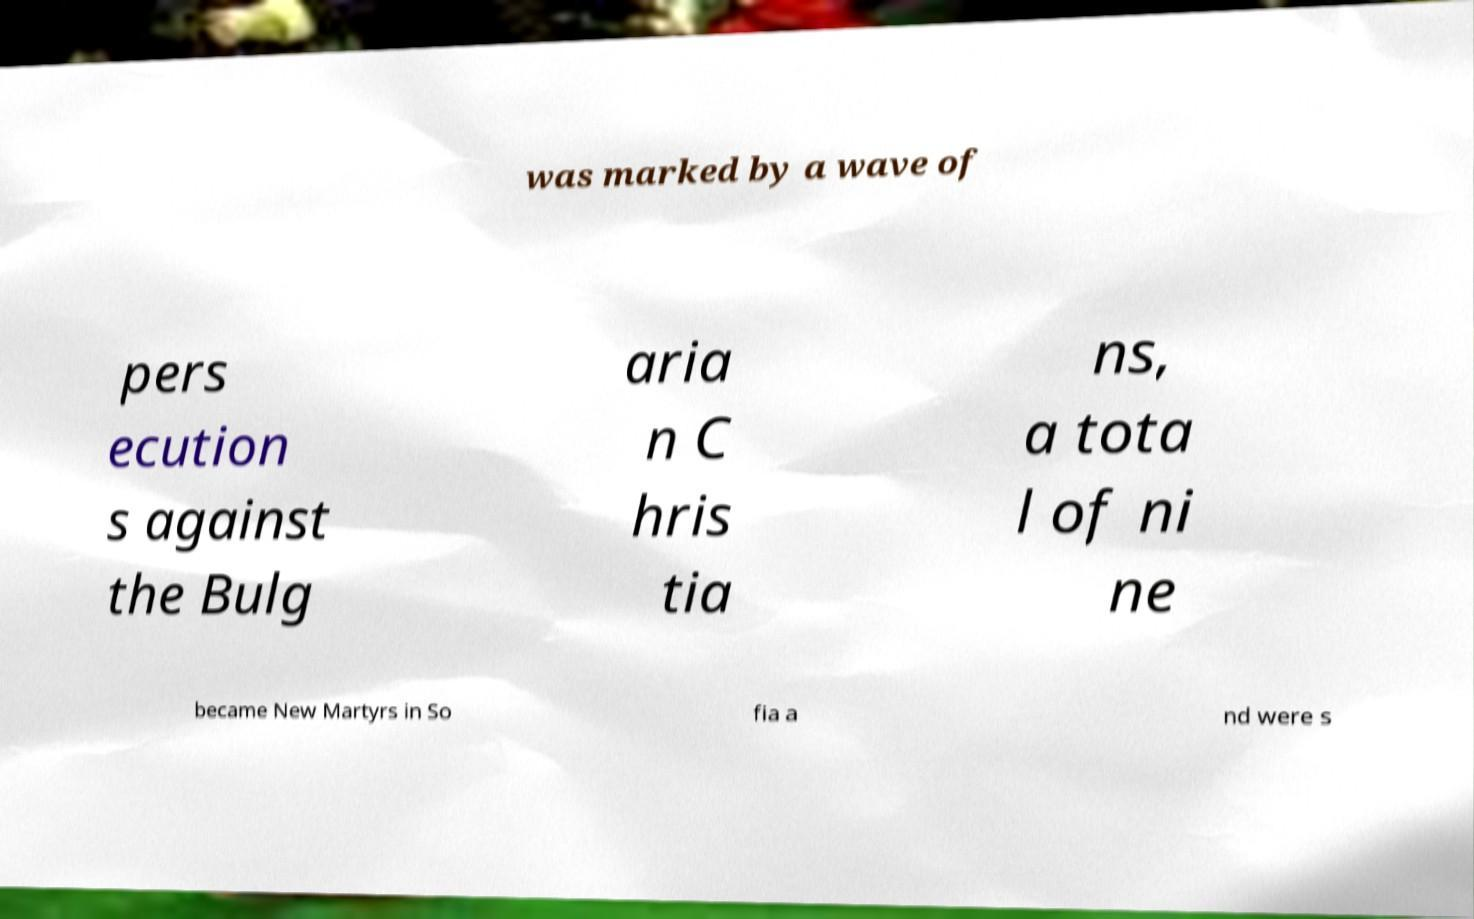Could you extract and type out the text from this image? was marked by a wave of pers ecution s against the Bulg aria n C hris tia ns, a tota l of ni ne became New Martyrs in So fia a nd were s 